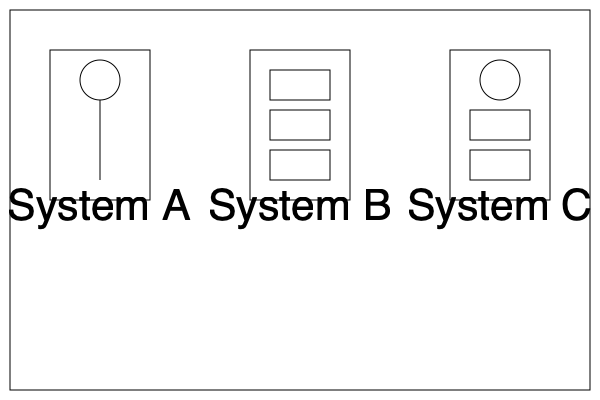Based on the schematic diagrams shown, which water filter system would you recommend for removing both sediment and chemical contaminants? To determine the most suitable water filter system for removing both sediment and chemical contaminants, let's analyze each system:

1. System A:
   - Contains a single circular component connected to a vertical line.
   - This likely represents a simple single-stage filtration system, such as a sediment filter.
   - It's effective for removing larger particles but not chemical contaminants.

2. System B:
   - Shows three rectangular components stacked vertically.
   - This represents a multi-stage filtration system.
   - Each stage can target different contaminants, including sediment and chemicals.
   - The multiple stages allow for comprehensive filtration.

3. System C:
   - Combines a circular component (similar to System A) with two rectangular components (similar to System B).
   - This hybrid system likely incorporates both sediment filtration (circular component) and chemical filtration (rectangular components).
   - It offers a balance of particle removal and chemical treatment.

Given the requirement to remove both sediment and chemical contaminants, System B or System C would be more suitable than System A. However, System B, with its three distinct stages, offers the most comprehensive filtration capabilities and flexibility in targeting various contaminants.
Answer: System B 